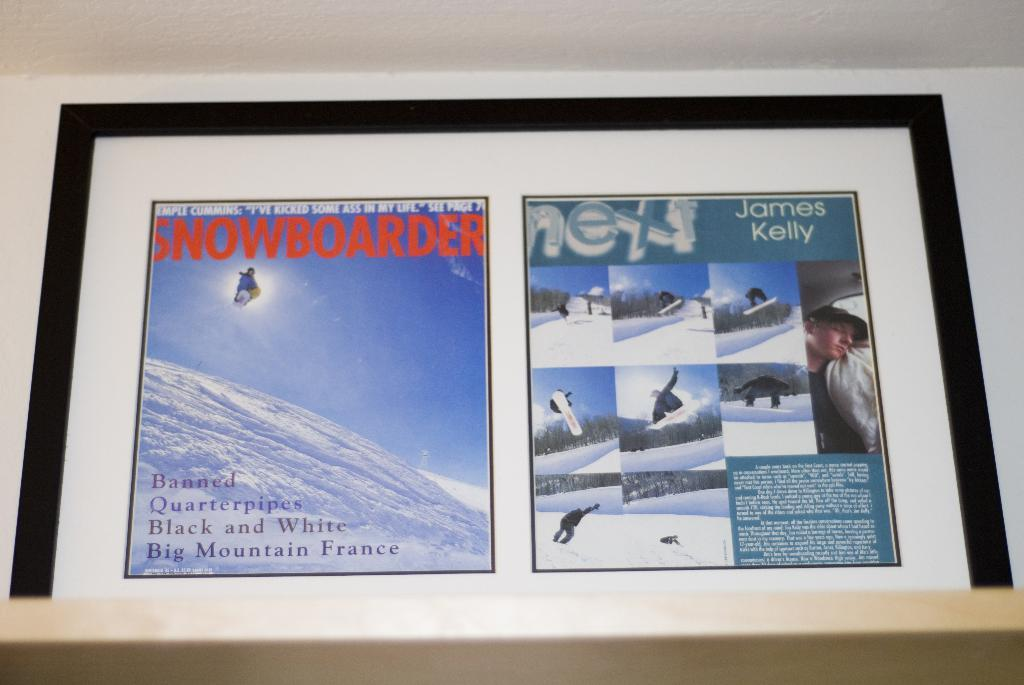<image>
Present a compact description of the photo's key features. Snowboarder that is soaring high and has the text Banned, Quarterpipes, Black and White, Big Mountain France, and James Kelly on the right. 